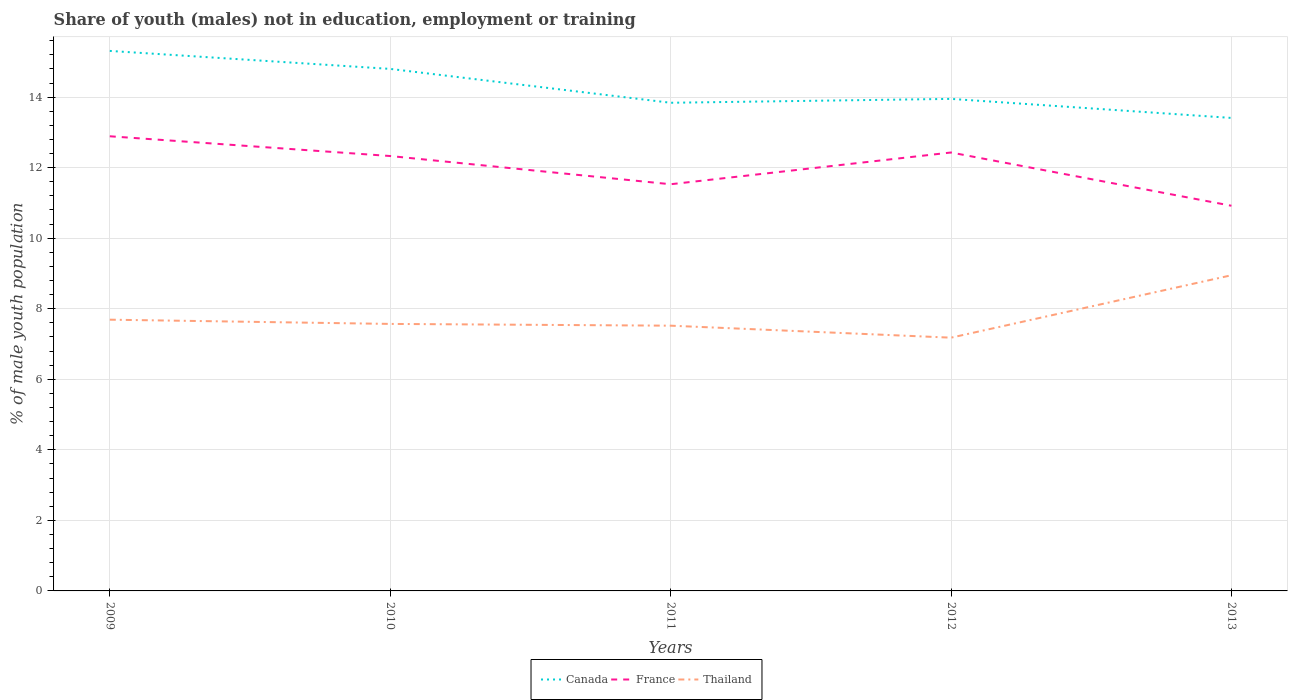How many different coloured lines are there?
Offer a very short reply. 3. Does the line corresponding to Thailand intersect with the line corresponding to Canada?
Offer a very short reply. No. Is the number of lines equal to the number of legend labels?
Your answer should be very brief. Yes. Across all years, what is the maximum percentage of unemployed males population in in Canada?
Give a very brief answer. 13.41. What is the total percentage of unemployed males population in in France in the graph?
Keep it short and to the point. 1.97. What is the difference between the highest and the second highest percentage of unemployed males population in in Thailand?
Your answer should be very brief. 1.77. How many lines are there?
Offer a terse response. 3. How many years are there in the graph?
Your response must be concise. 5. What is the difference between two consecutive major ticks on the Y-axis?
Make the answer very short. 2. Are the values on the major ticks of Y-axis written in scientific E-notation?
Ensure brevity in your answer.  No. Does the graph contain any zero values?
Offer a terse response. No. Does the graph contain grids?
Provide a short and direct response. Yes. How many legend labels are there?
Keep it short and to the point. 3. What is the title of the graph?
Keep it short and to the point. Share of youth (males) not in education, employment or training. What is the label or title of the X-axis?
Ensure brevity in your answer.  Years. What is the label or title of the Y-axis?
Give a very brief answer. % of male youth population. What is the % of male youth population of Canada in 2009?
Your response must be concise. 15.31. What is the % of male youth population of France in 2009?
Make the answer very short. 12.89. What is the % of male youth population in Thailand in 2009?
Ensure brevity in your answer.  7.69. What is the % of male youth population in Canada in 2010?
Provide a succinct answer. 14.8. What is the % of male youth population in France in 2010?
Provide a succinct answer. 12.33. What is the % of male youth population of Thailand in 2010?
Your response must be concise. 7.57. What is the % of male youth population in Canada in 2011?
Give a very brief answer. 13.84. What is the % of male youth population of France in 2011?
Offer a terse response. 11.53. What is the % of male youth population in Thailand in 2011?
Keep it short and to the point. 7.52. What is the % of male youth population of Canada in 2012?
Give a very brief answer. 13.95. What is the % of male youth population in France in 2012?
Your response must be concise. 12.43. What is the % of male youth population in Thailand in 2012?
Your response must be concise. 7.18. What is the % of male youth population of Canada in 2013?
Offer a terse response. 13.41. What is the % of male youth population of France in 2013?
Your answer should be very brief. 10.92. What is the % of male youth population in Thailand in 2013?
Your answer should be very brief. 8.95. Across all years, what is the maximum % of male youth population in Canada?
Offer a very short reply. 15.31. Across all years, what is the maximum % of male youth population of France?
Give a very brief answer. 12.89. Across all years, what is the maximum % of male youth population in Thailand?
Give a very brief answer. 8.95. Across all years, what is the minimum % of male youth population in Canada?
Make the answer very short. 13.41. Across all years, what is the minimum % of male youth population of France?
Your answer should be compact. 10.92. Across all years, what is the minimum % of male youth population in Thailand?
Offer a terse response. 7.18. What is the total % of male youth population in Canada in the graph?
Give a very brief answer. 71.31. What is the total % of male youth population of France in the graph?
Offer a terse response. 60.1. What is the total % of male youth population of Thailand in the graph?
Provide a succinct answer. 38.91. What is the difference between the % of male youth population in Canada in 2009 and that in 2010?
Offer a very short reply. 0.51. What is the difference between the % of male youth population of France in 2009 and that in 2010?
Your response must be concise. 0.56. What is the difference between the % of male youth population of Thailand in 2009 and that in 2010?
Give a very brief answer. 0.12. What is the difference between the % of male youth population of Canada in 2009 and that in 2011?
Offer a very short reply. 1.47. What is the difference between the % of male youth population of France in 2009 and that in 2011?
Your answer should be compact. 1.36. What is the difference between the % of male youth population of Thailand in 2009 and that in 2011?
Provide a succinct answer. 0.17. What is the difference between the % of male youth population in Canada in 2009 and that in 2012?
Make the answer very short. 1.36. What is the difference between the % of male youth population of France in 2009 and that in 2012?
Offer a terse response. 0.46. What is the difference between the % of male youth population in Thailand in 2009 and that in 2012?
Your response must be concise. 0.51. What is the difference between the % of male youth population in France in 2009 and that in 2013?
Keep it short and to the point. 1.97. What is the difference between the % of male youth population in Thailand in 2009 and that in 2013?
Ensure brevity in your answer.  -1.26. What is the difference between the % of male youth population of Canada in 2010 and that in 2011?
Provide a succinct answer. 0.96. What is the difference between the % of male youth population in France in 2010 and that in 2012?
Provide a succinct answer. -0.1. What is the difference between the % of male youth population in Thailand in 2010 and that in 2012?
Your answer should be compact. 0.39. What is the difference between the % of male youth population in Canada in 2010 and that in 2013?
Provide a succinct answer. 1.39. What is the difference between the % of male youth population of France in 2010 and that in 2013?
Keep it short and to the point. 1.41. What is the difference between the % of male youth population of Thailand in 2010 and that in 2013?
Give a very brief answer. -1.38. What is the difference between the % of male youth population in Canada in 2011 and that in 2012?
Offer a very short reply. -0.11. What is the difference between the % of male youth population in Thailand in 2011 and that in 2012?
Provide a short and direct response. 0.34. What is the difference between the % of male youth population in Canada in 2011 and that in 2013?
Your answer should be compact. 0.43. What is the difference between the % of male youth population in France in 2011 and that in 2013?
Your answer should be compact. 0.61. What is the difference between the % of male youth population in Thailand in 2011 and that in 2013?
Your response must be concise. -1.43. What is the difference between the % of male youth population of Canada in 2012 and that in 2013?
Offer a very short reply. 0.54. What is the difference between the % of male youth population of France in 2012 and that in 2013?
Provide a short and direct response. 1.51. What is the difference between the % of male youth population of Thailand in 2012 and that in 2013?
Offer a terse response. -1.77. What is the difference between the % of male youth population of Canada in 2009 and the % of male youth population of France in 2010?
Provide a succinct answer. 2.98. What is the difference between the % of male youth population of Canada in 2009 and the % of male youth population of Thailand in 2010?
Give a very brief answer. 7.74. What is the difference between the % of male youth population of France in 2009 and the % of male youth population of Thailand in 2010?
Ensure brevity in your answer.  5.32. What is the difference between the % of male youth population in Canada in 2009 and the % of male youth population in France in 2011?
Your answer should be very brief. 3.78. What is the difference between the % of male youth population in Canada in 2009 and the % of male youth population in Thailand in 2011?
Offer a terse response. 7.79. What is the difference between the % of male youth population in France in 2009 and the % of male youth population in Thailand in 2011?
Provide a succinct answer. 5.37. What is the difference between the % of male youth population of Canada in 2009 and the % of male youth population of France in 2012?
Make the answer very short. 2.88. What is the difference between the % of male youth population in Canada in 2009 and the % of male youth population in Thailand in 2012?
Offer a very short reply. 8.13. What is the difference between the % of male youth population in France in 2009 and the % of male youth population in Thailand in 2012?
Give a very brief answer. 5.71. What is the difference between the % of male youth population in Canada in 2009 and the % of male youth population in France in 2013?
Your response must be concise. 4.39. What is the difference between the % of male youth population of Canada in 2009 and the % of male youth population of Thailand in 2013?
Your answer should be compact. 6.36. What is the difference between the % of male youth population in France in 2009 and the % of male youth population in Thailand in 2013?
Provide a short and direct response. 3.94. What is the difference between the % of male youth population of Canada in 2010 and the % of male youth population of France in 2011?
Ensure brevity in your answer.  3.27. What is the difference between the % of male youth population of Canada in 2010 and the % of male youth population of Thailand in 2011?
Your response must be concise. 7.28. What is the difference between the % of male youth population of France in 2010 and the % of male youth population of Thailand in 2011?
Your answer should be compact. 4.81. What is the difference between the % of male youth population in Canada in 2010 and the % of male youth population in France in 2012?
Your answer should be compact. 2.37. What is the difference between the % of male youth population of Canada in 2010 and the % of male youth population of Thailand in 2012?
Provide a succinct answer. 7.62. What is the difference between the % of male youth population in France in 2010 and the % of male youth population in Thailand in 2012?
Give a very brief answer. 5.15. What is the difference between the % of male youth population of Canada in 2010 and the % of male youth population of France in 2013?
Offer a terse response. 3.88. What is the difference between the % of male youth population in Canada in 2010 and the % of male youth population in Thailand in 2013?
Provide a short and direct response. 5.85. What is the difference between the % of male youth population in France in 2010 and the % of male youth population in Thailand in 2013?
Offer a very short reply. 3.38. What is the difference between the % of male youth population of Canada in 2011 and the % of male youth population of France in 2012?
Make the answer very short. 1.41. What is the difference between the % of male youth population of Canada in 2011 and the % of male youth population of Thailand in 2012?
Keep it short and to the point. 6.66. What is the difference between the % of male youth population of France in 2011 and the % of male youth population of Thailand in 2012?
Keep it short and to the point. 4.35. What is the difference between the % of male youth population in Canada in 2011 and the % of male youth population in France in 2013?
Keep it short and to the point. 2.92. What is the difference between the % of male youth population of Canada in 2011 and the % of male youth population of Thailand in 2013?
Provide a short and direct response. 4.89. What is the difference between the % of male youth population in France in 2011 and the % of male youth population in Thailand in 2013?
Keep it short and to the point. 2.58. What is the difference between the % of male youth population of Canada in 2012 and the % of male youth population of France in 2013?
Give a very brief answer. 3.03. What is the difference between the % of male youth population in France in 2012 and the % of male youth population in Thailand in 2013?
Offer a very short reply. 3.48. What is the average % of male youth population in Canada per year?
Keep it short and to the point. 14.26. What is the average % of male youth population of France per year?
Offer a terse response. 12.02. What is the average % of male youth population in Thailand per year?
Give a very brief answer. 7.78. In the year 2009, what is the difference between the % of male youth population in Canada and % of male youth population in France?
Provide a succinct answer. 2.42. In the year 2009, what is the difference between the % of male youth population in Canada and % of male youth population in Thailand?
Offer a very short reply. 7.62. In the year 2010, what is the difference between the % of male youth population of Canada and % of male youth population of France?
Provide a short and direct response. 2.47. In the year 2010, what is the difference between the % of male youth population in Canada and % of male youth population in Thailand?
Provide a succinct answer. 7.23. In the year 2010, what is the difference between the % of male youth population in France and % of male youth population in Thailand?
Offer a very short reply. 4.76. In the year 2011, what is the difference between the % of male youth population of Canada and % of male youth population of France?
Your answer should be compact. 2.31. In the year 2011, what is the difference between the % of male youth population in Canada and % of male youth population in Thailand?
Your answer should be very brief. 6.32. In the year 2011, what is the difference between the % of male youth population in France and % of male youth population in Thailand?
Your response must be concise. 4.01. In the year 2012, what is the difference between the % of male youth population in Canada and % of male youth population in France?
Offer a terse response. 1.52. In the year 2012, what is the difference between the % of male youth population of Canada and % of male youth population of Thailand?
Provide a short and direct response. 6.77. In the year 2012, what is the difference between the % of male youth population of France and % of male youth population of Thailand?
Your answer should be very brief. 5.25. In the year 2013, what is the difference between the % of male youth population in Canada and % of male youth population in France?
Ensure brevity in your answer.  2.49. In the year 2013, what is the difference between the % of male youth population in Canada and % of male youth population in Thailand?
Your answer should be compact. 4.46. In the year 2013, what is the difference between the % of male youth population in France and % of male youth population in Thailand?
Offer a very short reply. 1.97. What is the ratio of the % of male youth population in Canada in 2009 to that in 2010?
Your answer should be very brief. 1.03. What is the ratio of the % of male youth population of France in 2009 to that in 2010?
Provide a short and direct response. 1.05. What is the ratio of the % of male youth population in Thailand in 2009 to that in 2010?
Your answer should be compact. 1.02. What is the ratio of the % of male youth population in Canada in 2009 to that in 2011?
Provide a succinct answer. 1.11. What is the ratio of the % of male youth population of France in 2009 to that in 2011?
Ensure brevity in your answer.  1.12. What is the ratio of the % of male youth population in Thailand in 2009 to that in 2011?
Offer a terse response. 1.02. What is the ratio of the % of male youth population of Canada in 2009 to that in 2012?
Offer a terse response. 1.1. What is the ratio of the % of male youth population in Thailand in 2009 to that in 2012?
Provide a succinct answer. 1.07. What is the ratio of the % of male youth population in Canada in 2009 to that in 2013?
Make the answer very short. 1.14. What is the ratio of the % of male youth population in France in 2009 to that in 2013?
Provide a short and direct response. 1.18. What is the ratio of the % of male youth population in Thailand in 2009 to that in 2013?
Provide a short and direct response. 0.86. What is the ratio of the % of male youth population of Canada in 2010 to that in 2011?
Provide a succinct answer. 1.07. What is the ratio of the % of male youth population of France in 2010 to that in 2011?
Offer a very short reply. 1.07. What is the ratio of the % of male youth population in Thailand in 2010 to that in 2011?
Provide a short and direct response. 1.01. What is the ratio of the % of male youth population of Canada in 2010 to that in 2012?
Offer a very short reply. 1.06. What is the ratio of the % of male youth population in Thailand in 2010 to that in 2012?
Give a very brief answer. 1.05. What is the ratio of the % of male youth population in Canada in 2010 to that in 2013?
Make the answer very short. 1.1. What is the ratio of the % of male youth population in France in 2010 to that in 2013?
Keep it short and to the point. 1.13. What is the ratio of the % of male youth population in Thailand in 2010 to that in 2013?
Keep it short and to the point. 0.85. What is the ratio of the % of male youth population of Canada in 2011 to that in 2012?
Ensure brevity in your answer.  0.99. What is the ratio of the % of male youth population in France in 2011 to that in 2012?
Your response must be concise. 0.93. What is the ratio of the % of male youth population in Thailand in 2011 to that in 2012?
Your response must be concise. 1.05. What is the ratio of the % of male youth population of Canada in 2011 to that in 2013?
Your answer should be compact. 1.03. What is the ratio of the % of male youth population of France in 2011 to that in 2013?
Provide a succinct answer. 1.06. What is the ratio of the % of male youth population of Thailand in 2011 to that in 2013?
Your answer should be compact. 0.84. What is the ratio of the % of male youth population in Canada in 2012 to that in 2013?
Ensure brevity in your answer.  1.04. What is the ratio of the % of male youth population in France in 2012 to that in 2013?
Provide a short and direct response. 1.14. What is the ratio of the % of male youth population in Thailand in 2012 to that in 2013?
Offer a very short reply. 0.8. What is the difference between the highest and the second highest % of male youth population of Canada?
Give a very brief answer. 0.51. What is the difference between the highest and the second highest % of male youth population in France?
Offer a terse response. 0.46. What is the difference between the highest and the second highest % of male youth population in Thailand?
Your answer should be compact. 1.26. What is the difference between the highest and the lowest % of male youth population of France?
Your answer should be very brief. 1.97. What is the difference between the highest and the lowest % of male youth population of Thailand?
Your response must be concise. 1.77. 